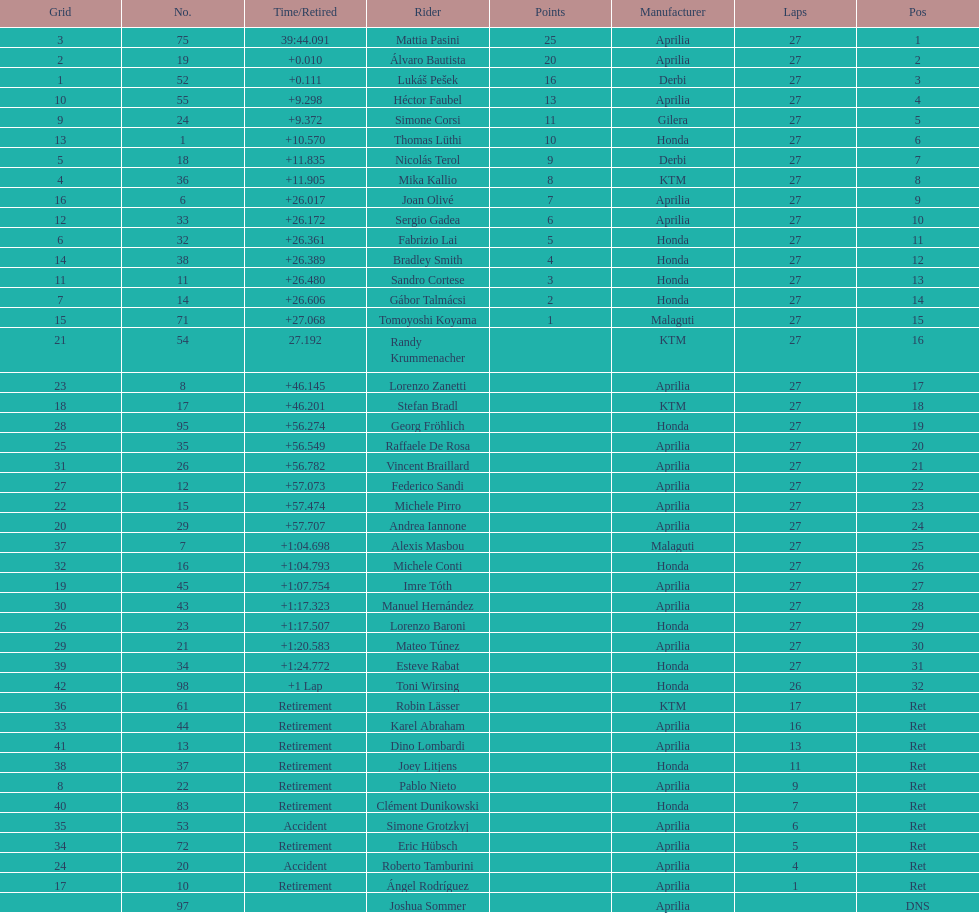How many racers did not use an aprilia or a honda? 9. 